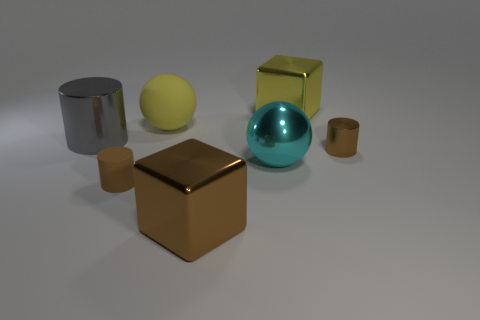Is there any other thing that has the same material as the big yellow sphere?
Your answer should be very brief. Yes. How many shiny objects are both in front of the yellow rubber thing and left of the tiny metallic cylinder?
Your response must be concise. 3. What number of things are either metal objects that are left of the tiny metal cylinder or brown shiny objects behind the brown shiny cube?
Provide a short and direct response. 5. How many other things are the same shape as the large cyan metallic object?
Your answer should be compact. 1. There is a big sphere that is in front of the large gray shiny object; does it have the same color as the small rubber cylinder?
Keep it short and to the point. No. How many other things are there of the same size as the cyan sphere?
Offer a terse response. 4. Are the cyan ball and the brown block made of the same material?
Provide a succinct answer. Yes. There is a large metal cube that is in front of the metallic block that is behind the rubber cylinder; what color is it?
Offer a very short reply. Brown. The other matte object that is the same shape as the cyan thing is what size?
Your answer should be very brief. Large. Is the color of the shiny ball the same as the tiny shiny cylinder?
Provide a short and direct response. No. 